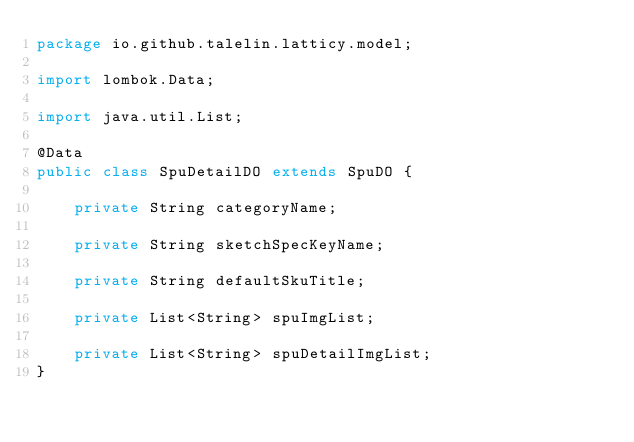<code> <loc_0><loc_0><loc_500><loc_500><_Java_>package io.github.talelin.latticy.model;

import lombok.Data;

import java.util.List;

@Data
public class SpuDetailDO extends SpuDO {

    private String categoryName;

    private String sketchSpecKeyName;

    private String defaultSkuTitle;

    private List<String> spuImgList;

    private List<String> spuDetailImgList;
}
</code> 